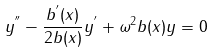<formula> <loc_0><loc_0><loc_500><loc_500>y ^ { ^ { \prime \prime } } - \frac { b ^ { ^ { \prime } } ( x ) } { 2 b ( x ) } y ^ { ^ { \prime } } + \omega ^ { 2 } b ( x ) y = 0</formula> 